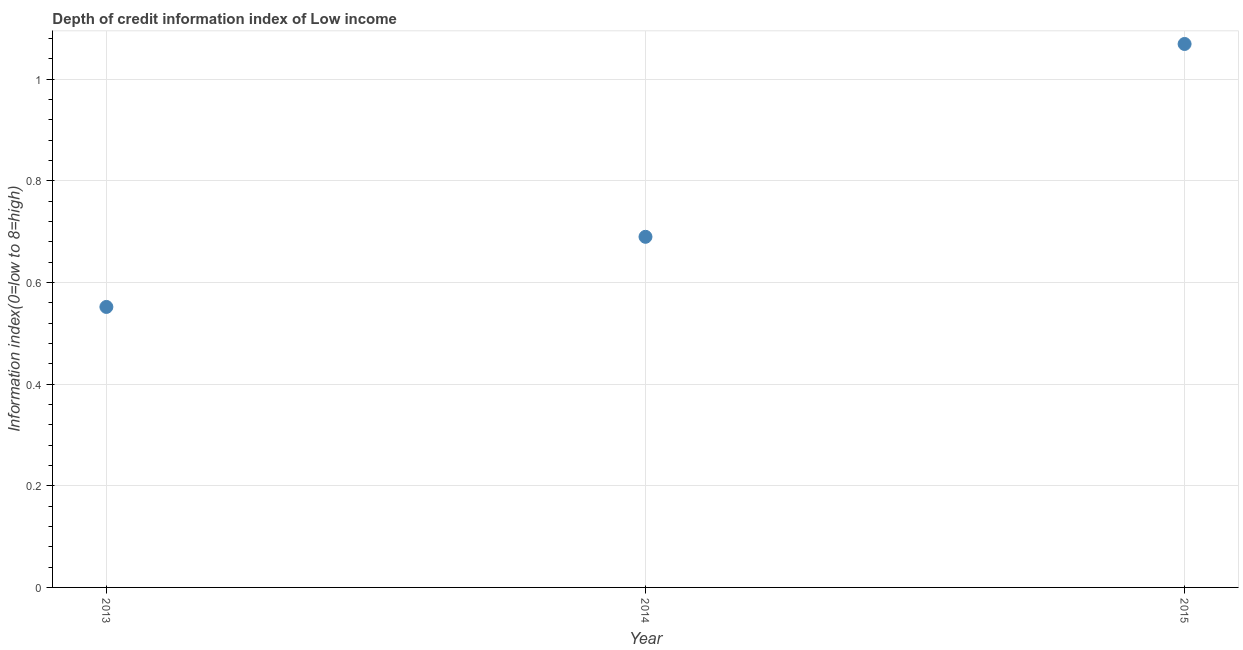What is the depth of credit information index in 2014?
Your answer should be very brief. 0.69. Across all years, what is the maximum depth of credit information index?
Make the answer very short. 1.07. Across all years, what is the minimum depth of credit information index?
Ensure brevity in your answer.  0.55. In which year was the depth of credit information index maximum?
Provide a short and direct response. 2015. What is the sum of the depth of credit information index?
Your response must be concise. 2.31. What is the difference between the depth of credit information index in 2013 and 2015?
Provide a short and direct response. -0.52. What is the average depth of credit information index per year?
Provide a short and direct response. 0.77. What is the median depth of credit information index?
Make the answer very short. 0.69. In how many years, is the depth of credit information index greater than 0.2 ?
Your answer should be compact. 3. Do a majority of the years between 2014 and 2013 (inclusive) have depth of credit information index greater than 0.7600000000000001 ?
Provide a short and direct response. No. What is the ratio of the depth of credit information index in 2013 to that in 2015?
Offer a very short reply. 0.52. Is the difference between the depth of credit information index in 2013 and 2014 greater than the difference between any two years?
Your answer should be compact. No. What is the difference between the highest and the second highest depth of credit information index?
Provide a succinct answer. 0.38. What is the difference between the highest and the lowest depth of credit information index?
Keep it short and to the point. 0.52. In how many years, is the depth of credit information index greater than the average depth of credit information index taken over all years?
Offer a terse response. 1. Does the depth of credit information index monotonically increase over the years?
Your answer should be compact. Yes. How many years are there in the graph?
Your answer should be compact. 3. Does the graph contain any zero values?
Provide a succinct answer. No. What is the title of the graph?
Offer a very short reply. Depth of credit information index of Low income. What is the label or title of the X-axis?
Provide a succinct answer. Year. What is the label or title of the Y-axis?
Ensure brevity in your answer.  Information index(0=low to 8=high). What is the Information index(0=low to 8=high) in 2013?
Ensure brevity in your answer.  0.55. What is the Information index(0=low to 8=high) in 2014?
Provide a short and direct response. 0.69. What is the Information index(0=low to 8=high) in 2015?
Keep it short and to the point. 1.07. What is the difference between the Information index(0=low to 8=high) in 2013 and 2014?
Give a very brief answer. -0.14. What is the difference between the Information index(0=low to 8=high) in 2013 and 2015?
Provide a succinct answer. -0.52. What is the difference between the Information index(0=low to 8=high) in 2014 and 2015?
Keep it short and to the point. -0.38. What is the ratio of the Information index(0=low to 8=high) in 2013 to that in 2014?
Your answer should be very brief. 0.8. What is the ratio of the Information index(0=low to 8=high) in 2013 to that in 2015?
Ensure brevity in your answer.  0.52. What is the ratio of the Information index(0=low to 8=high) in 2014 to that in 2015?
Provide a succinct answer. 0.65. 